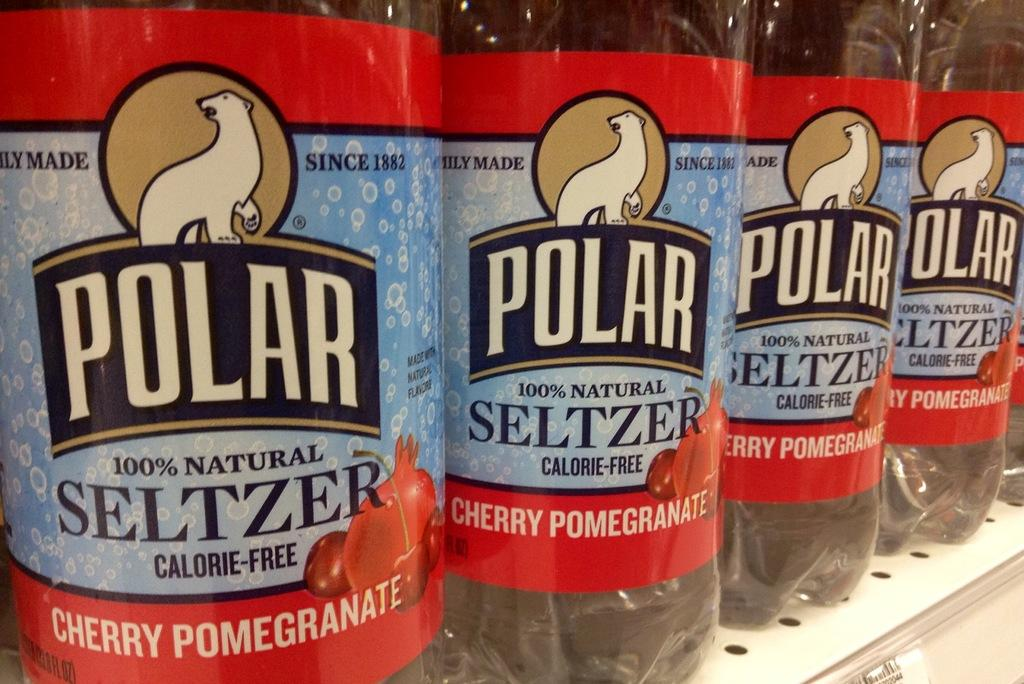<image>
Create a compact narrative representing the image presented. a polar seltzer item among many different ones 